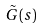Convert formula to latex. <formula><loc_0><loc_0><loc_500><loc_500>\tilde { G } ( s )</formula> 